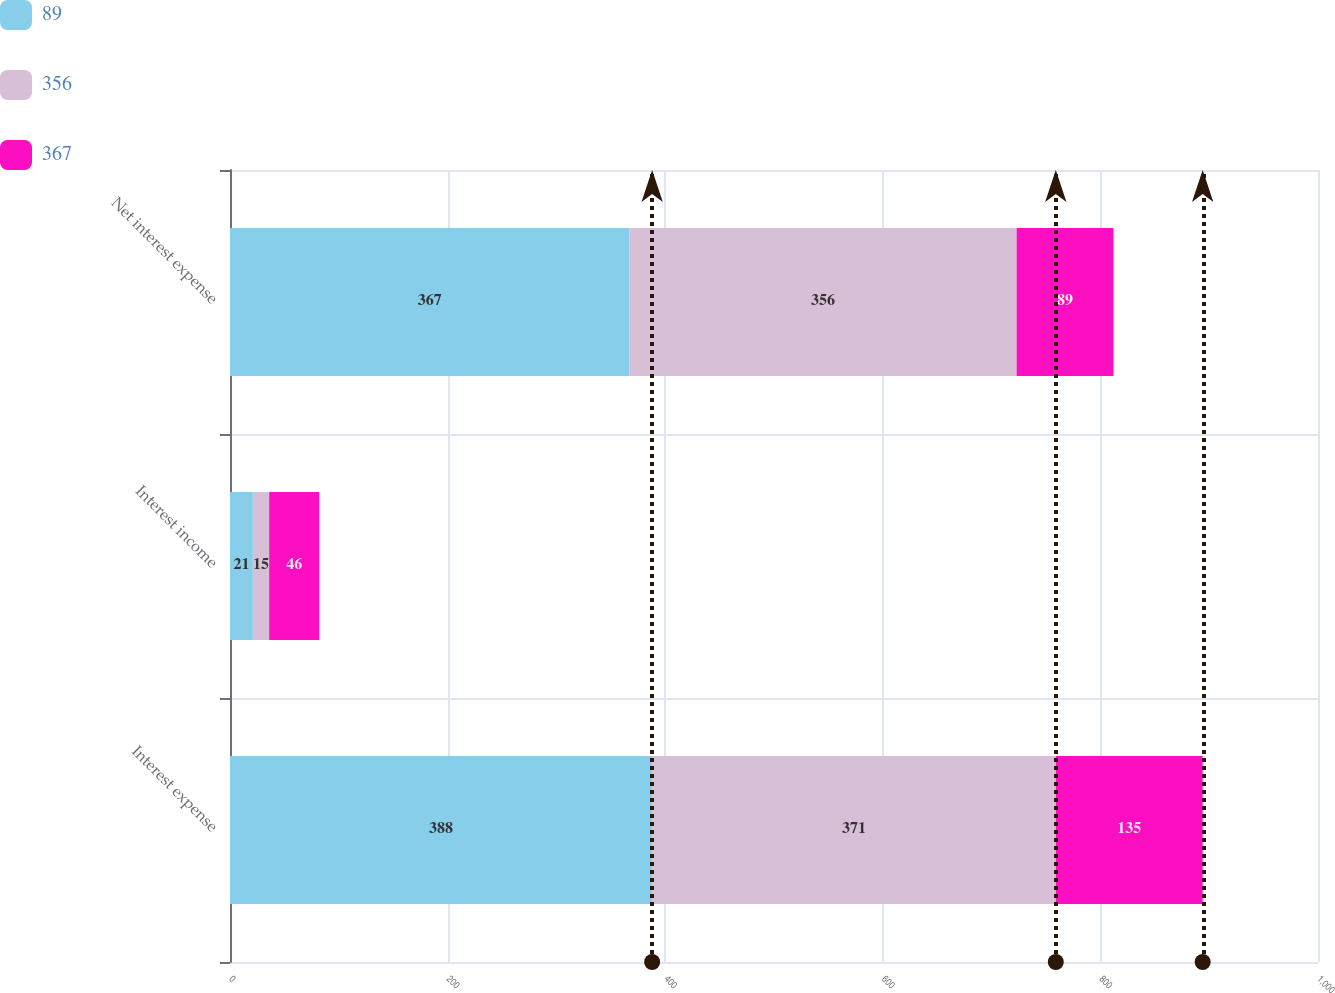Convert chart. <chart><loc_0><loc_0><loc_500><loc_500><stacked_bar_chart><ecel><fcel>Interest expense<fcel>Interest income<fcel>Net interest expense<nl><fcel>89<fcel>388<fcel>21<fcel>367<nl><fcel>356<fcel>371<fcel>15<fcel>356<nl><fcel>367<fcel>135<fcel>46<fcel>89<nl></chart> 